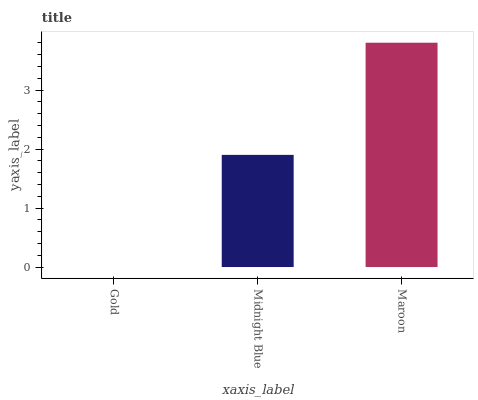Is Gold the minimum?
Answer yes or no. Yes. Is Maroon the maximum?
Answer yes or no. Yes. Is Midnight Blue the minimum?
Answer yes or no. No. Is Midnight Blue the maximum?
Answer yes or no. No. Is Midnight Blue greater than Gold?
Answer yes or no. Yes. Is Gold less than Midnight Blue?
Answer yes or no. Yes. Is Gold greater than Midnight Blue?
Answer yes or no. No. Is Midnight Blue less than Gold?
Answer yes or no. No. Is Midnight Blue the high median?
Answer yes or no. Yes. Is Midnight Blue the low median?
Answer yes or no. Yes. Is Maroon the high median?
Answer yes or no. No. Is Maroon the low median?
Answer yes or no. No. 